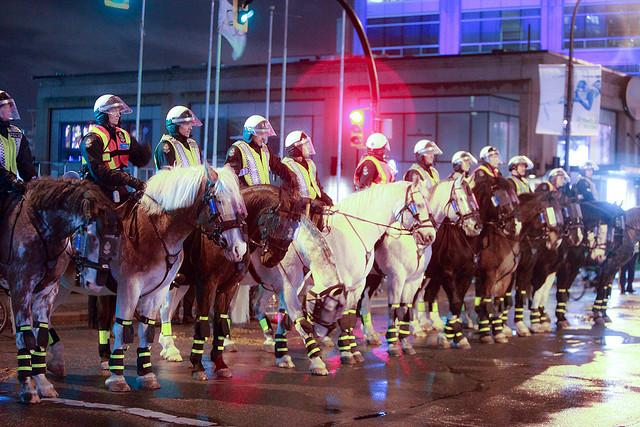What do the officers here observe? Please explain your reasoning. protest. The officers are wearing their uniforms and are mounted on their horses lined up ready to protect and defend the innocent. 